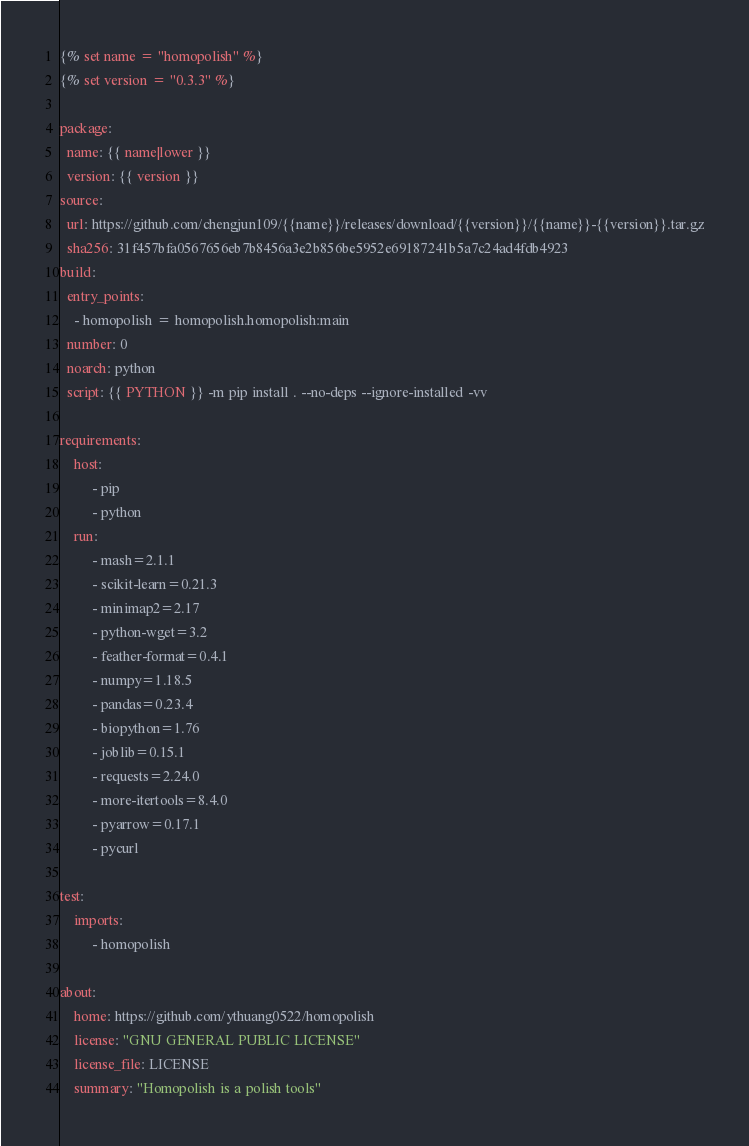Convert code to text. <code><loc_0><loc_0><loc_500><loc_500><_YAML_>{% set name = "homopolish" %}
{% set version = "0.3.3" %}

package:
  name: {{ name|lower }}
  version: {{ version }}
source:
  url: https://github.com/chengjun109/{{name}}/releases/download/{{version}}/{{name}}-{{version}}.tar.gz
  sha256: 31f457bfa0567656eb7b8456a3e2b856be5952e69187241b5a7c24ad4fdb4923
build:
  entry_points:
    - homopolish = homopolish.homopolish:main
  number: 0
  noarch: python
  script: {{ PYTHON }} -m pip install . --no-deps --ignore-installed -vv

requirements:
    host:
         - pip
         - python
    run:
         - mash=2.1.1
         - scikit-learn=0.21.3
         - minimap2=2.17
         - python-wget=3.2
         - feather-format=0.4.1
         - numpy=1.18.5
         - pandas=0.23.4
         - biopython=1.76
         - joblib=0.15.1
         - requests=2.24.0
         - more-itertools=8.4.0
         - pyarrow=0.17.1
         - pycurl

test:
    imports:
         - homopolish

about:
    home: https://github.com/ythuang0522/homopolish
    license: "GNU GENERAL PUBLIC LICENSE"
    license_file: LICENSE
    summary: "Homopolish is a polish tools"

</code> 